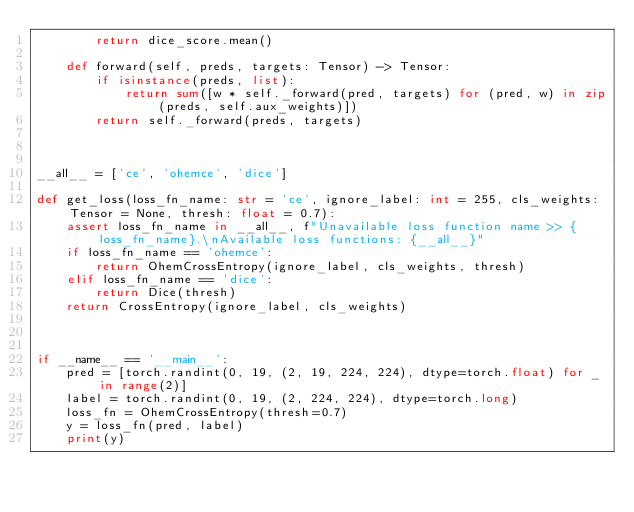<code> <loc_0><loc_0><loc_500><loc_500><_Python_>        return dice_score.mean()

    def forward(self, preds, targets: Tensor) -> Tensor:
        if isinstance(preds, list):
            return sum([w * self._forward(pred, targets) for (pred, w) in zip(preds, self.aux_weights)])
        return self._forward(preds, targets)



__all__ = ['ce', 'ohemce', 'dice']

def get_loss(loss_fn_name: str = 'ce', ignore_label: int = 255, cls_weights: Tensor = None, thresh: float = 0.7):
    assert loss_fn_name in __all__, f"Unavailable loss function name >> {loss_fn_name}.\nAvailable loss functions: {__all__}"
    if loss_fn_name == 'ohemce':
        return OhemCrossEntropy(ignore_label, cls_weights, thresh)
    elif loss_fn_name == 'dice':
        return Dice(thresh)
    return CrossEntropy(ignore_label, cls_weights)



if __name__ == '__main__':
    pred = [torch.randint(0, 19, (2, 19, 224, 224), dtype=torch.float) for _ in range(2)]
    label = torch.randint(0, 19, (2, 224, 224), dtype=torch.long)
    loss_fn = OhemCrossEntropy(thresh=0.7)
    y = loss_fn(pred, label)
    print(y)</code> 